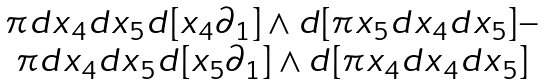<formula> <loc_0><loc_0><loc_500><loc_500>\begin{matrix} { { \pi d x } _ { 4 } } { { d x } _ { 5 } } d [ { x _ { 4 } } { \partial _ { 1 } } ] \wedge d [ { { \pi x } _ { 5 } } { { d x } _ { 4 } } { { d x } _ { 5 } } ] - \\ { { \pi d x } _ { 4 } } { { d x } _ { 5 } } d [ { x _ { 5 } } { \partial _ { 1 } } ] \wedge d [ { { \pi x } _ { 4 } } { { d x } _ { 4 } } { { d x } _ { 5 } } ] \end{matrix}</formula> 